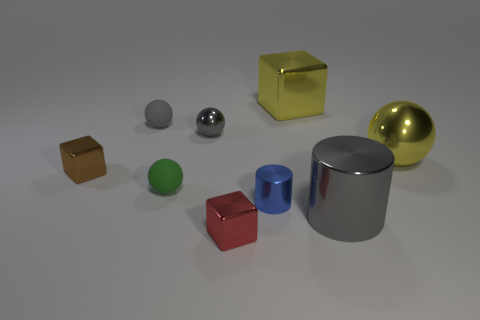Subtract 1 balls. How many balls are left? 3 Add 1 green matte things. How many objects exist? 10 Subtract all blocks. How many objects are left? 6 Add 4 gray metallic spheres. How many gray metallic spheres are left? 5 Add 9 small green rubber things. How many small green rubber things exist? 10 Subtract 1 blue cylinders. How many objects are left? 8 Subtract all small metallic blocks. Subtract all gray metal balls. How many objects are left? 6 